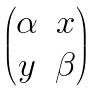<formula> <loc_0><loc_0><loc_500><loc_500>\begin{pmatrix} \alpha & x \\ y & \beta \end{pmatrix}</formula> 